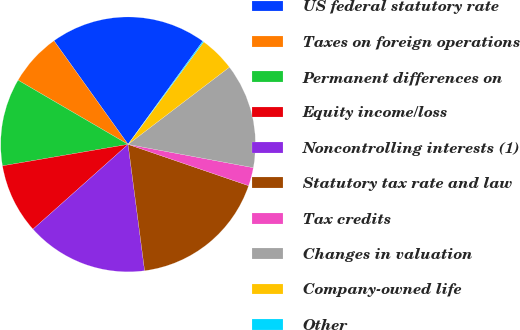Convert chart to OTSL. <chart><loc_0><loc_0><loc_500><loc_500><pie_chart><fcel>US federal statutory rate<fcel>Taxes on foreign operations<fcel>Permanent differences on<fcel>Equity income/loss<fcel>Noncontrolling interests (1)<fcel>Statutory tax rate and law<fcel>Tax credits<fcel>Changes in valuation<fcel>Company-owned life<fcel>Other<nl><fcel>19.86%<fcel>6.71%<fcel>11.1%<fcel>8.9%<fcel>15.48%<fcel>17.67%<fcel>2.33%<fcel>13.29%<fcel>4.52%<fcel>0.14%<nl></chart> 